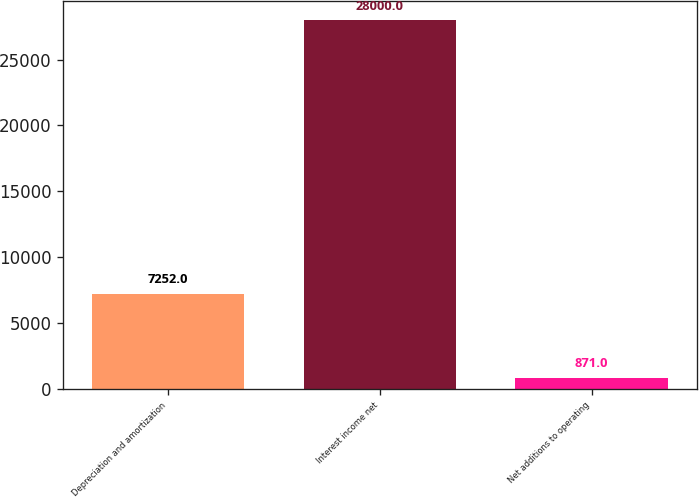Convert chart to OTSL. <chart><loc_0><loc_0><loc_500><loc_500><bar_chart><fcel>Depreciation and amortization<fcel>Interest income net<fcel>Net additions to operating<nl><fcel>7252<fcel>28000<fcel>871<nl></chart> 